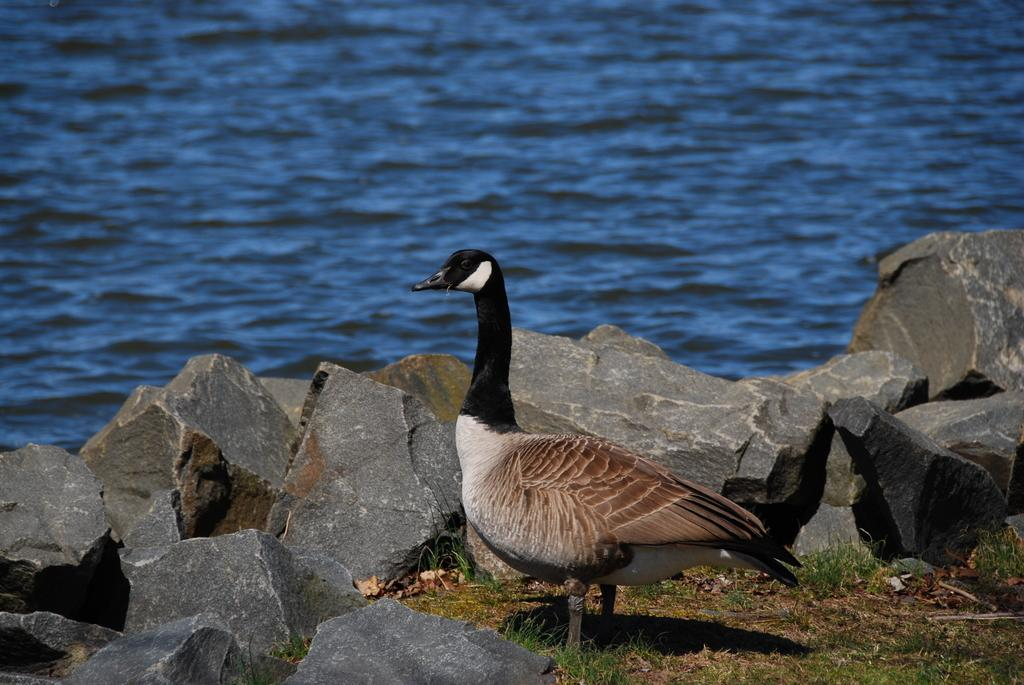What animal can be seen on the ground in the image? There is a goose on the ground in the image. What type of vegetation is visible in the image? There is grass visible in the image. What type of objects are present in the image? There is a group of stones in the image. What natural feature is present in the image? There is a large water body in the image. What type of shop can be seen in the image? There is no shop present in the image. What type of muscle is visible on the goose in the image? The image does not show the goose's muscles, and it is not possible to determine the type of muscle from the image. 